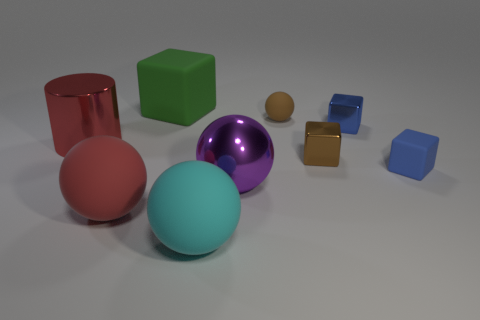Is there any other thing that has the same color as the large metallic sphere?
Your response must be concise. No. The large object that is in front of the sphere on the left side of the large green matte cube is what color?
Provide a succinct answer. Cyan. How many small brown spheres have the same material as the large block?
Offer a very short reply. 1. How many matte things are either small blue cubes or big red spheres?
Your response must be concise. 2. There is a brown block that is the same size as the blue shiny object; what is its material?
Your answer should be very brief. Metal. Are there any gray objects made of the same material as the big red ball?
Ensure brevity in your answer.  No. There is a blue thing behind the red object behind the blue object that is in front of the small blue metal cube; what is its shape?
Provide a succinct answer. Cube. Does the cylinder have the same size as the rubber cube that is behind the small brown rubber object?
Keep it short and to the point. Yes. The metal thing that is to the right of the purple metal sphere and in front of the blue metal thing has what shape?
Make the answer very short. Cube. How many small things are red shiny objects or blue matte blocks?
Your response must be concise. 1. 